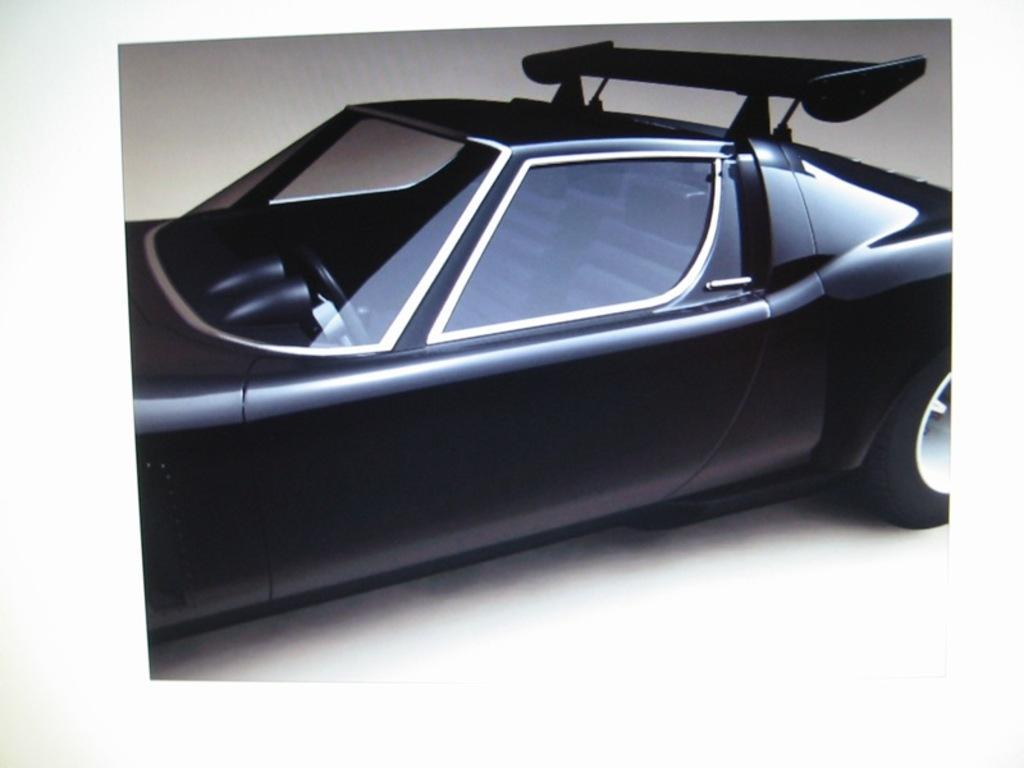What is the main subject of the image? There is a vehicle in the image. What type of card can be seen in the memory of the vehicle in the image? There is no card or memory present in the image; it only features a vehicle. 